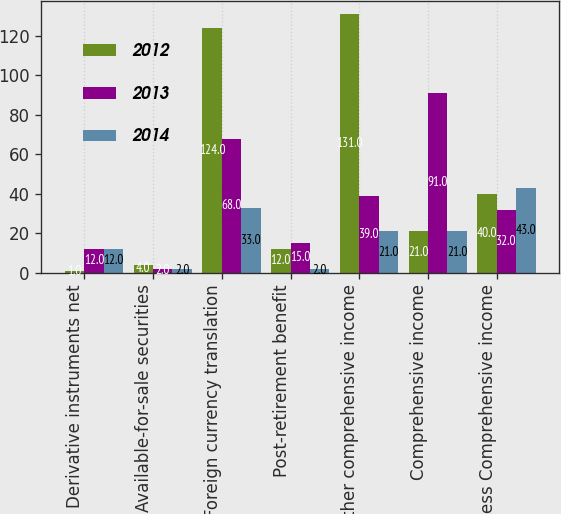Convert chart. <chart><loc_0><loc_0><loc_500><loc_500><stacked_bar_chart><ecel><fcel>Derivative instruments net<fcel>Available-for-sale securities<fcel>Foreign currency translation<fcel>Post-retirement benefit<fcel>Other comprehensive income<fcel>Comprehensive income<fcel>Less Comprehensive income<nl><fcel>2012<fcel>1<fcel>4<fcel>124<fcel>12<fcel>131<fcel>21<fcel>40<nl><fcel>2013<fcel>12<fcel>2<fcel>68<fcel>15<fcel>39<fcel>91<fcel>32<nl><fcel>2014<fcel>12<fcel>2<fcel>33<fcel>2<fcel>21<fcel>21<fcel>43<nl></chart> 